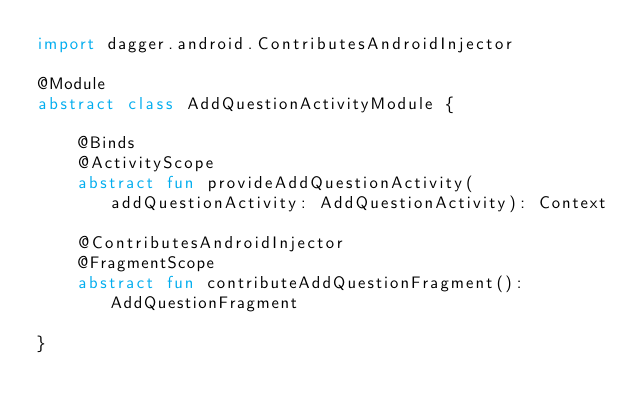<code> <loc_0><loc_0><loc_500><loc_500><_Kotlin_>import dagger.android.ContributesAndroidInjector

@Module
abstract class AddQuestionActivityModule {

    @Binds
    @ActivityScope
    abstract fun provideAddQuestionActivity(addQuestionActivity: AddQuestionActivity): Context

    @ContributesAndroidInjector
    @FragmentScope
    abstract fun contributeAddQuestionFragment(): AddQuestionFragment

}</code> 